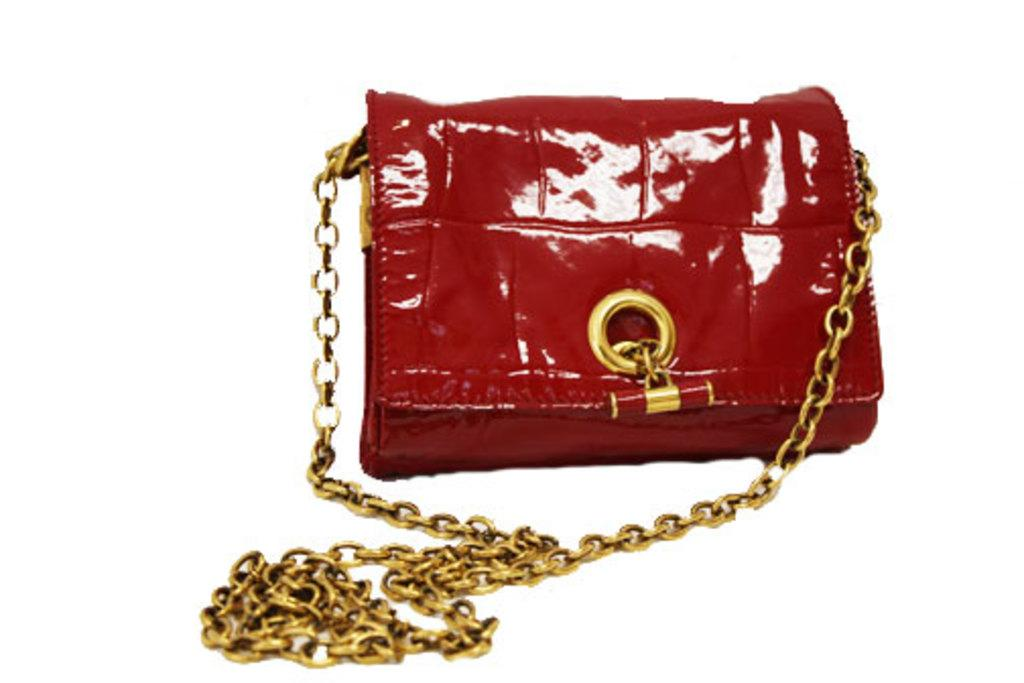What type of bag is visible in the image? There is a sling bag in the image. Can you describe the appearance of the sling bag? The sling bag is shiny and red. What material is used for the handle of the bag? The sling bag has a metal handle belt. How is the strap of the bag attached to the bag? One end of the strap is attached to the bag, and the other end is attached to the other side of the bag. How many pizzas are visible in the image? There are no pizzas present in the image; it features a sling bag. What type of tiger can be seen interacting with the sling bag in the image? There is no tiger present in the image; it features a sling bag with no animals interacting with it. 